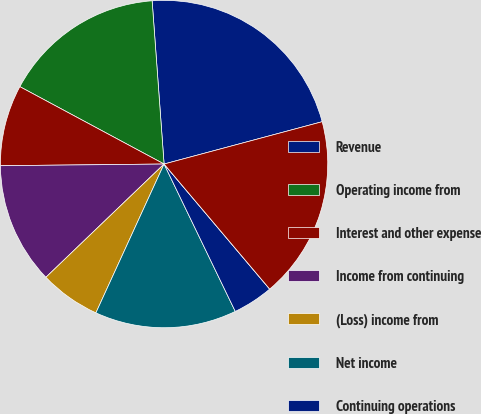Convert chart. <chart><loc_0><loc_0><loc_500><loc_500><pie_chart><fcel>Revenue<fcel>Operating income from<fcel>Interest and other expense<fcel>Income from continuing<fcel>(Loss) income from<fcel>Net income<fcel>Continuing operations<fcel>Discontinued operations<fcel>Basic<nl><fcel>22.0%<fcel>16.0%<fcel>8.0%<fcel>12.0%<fcel>6.0%<fcel>14.0%<fcel>4.0%<fcel>0.0%<fcel>18.0%<nl></chart> 